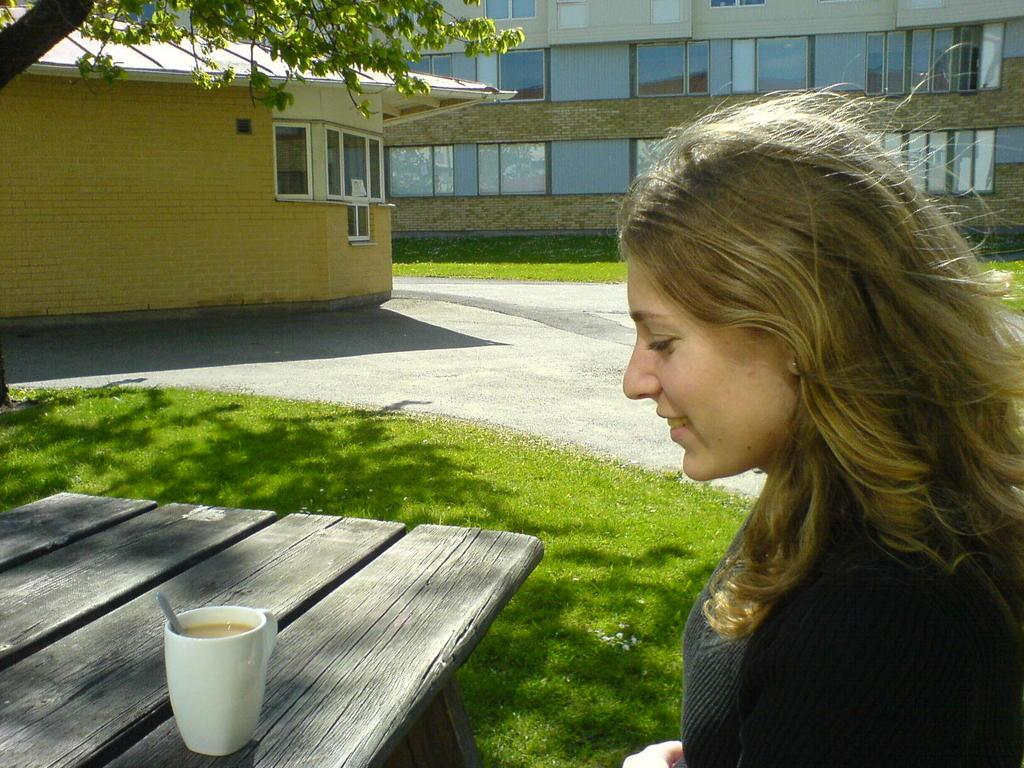Who is present in the image? There is a woman in the image. What is the woman's expression? The woman is smiling. What type of furniture is in the image? There is a wooden table in the image. What is on the table? There is a cup on the table. What type of structures can be seen in the image? There are buildings visible in the image. What type of plant is in the image? There is a tree in the image. What did the father do after the man left the room in the image? There is no father or man present in the image, and no action of leaving a room is depicted. 